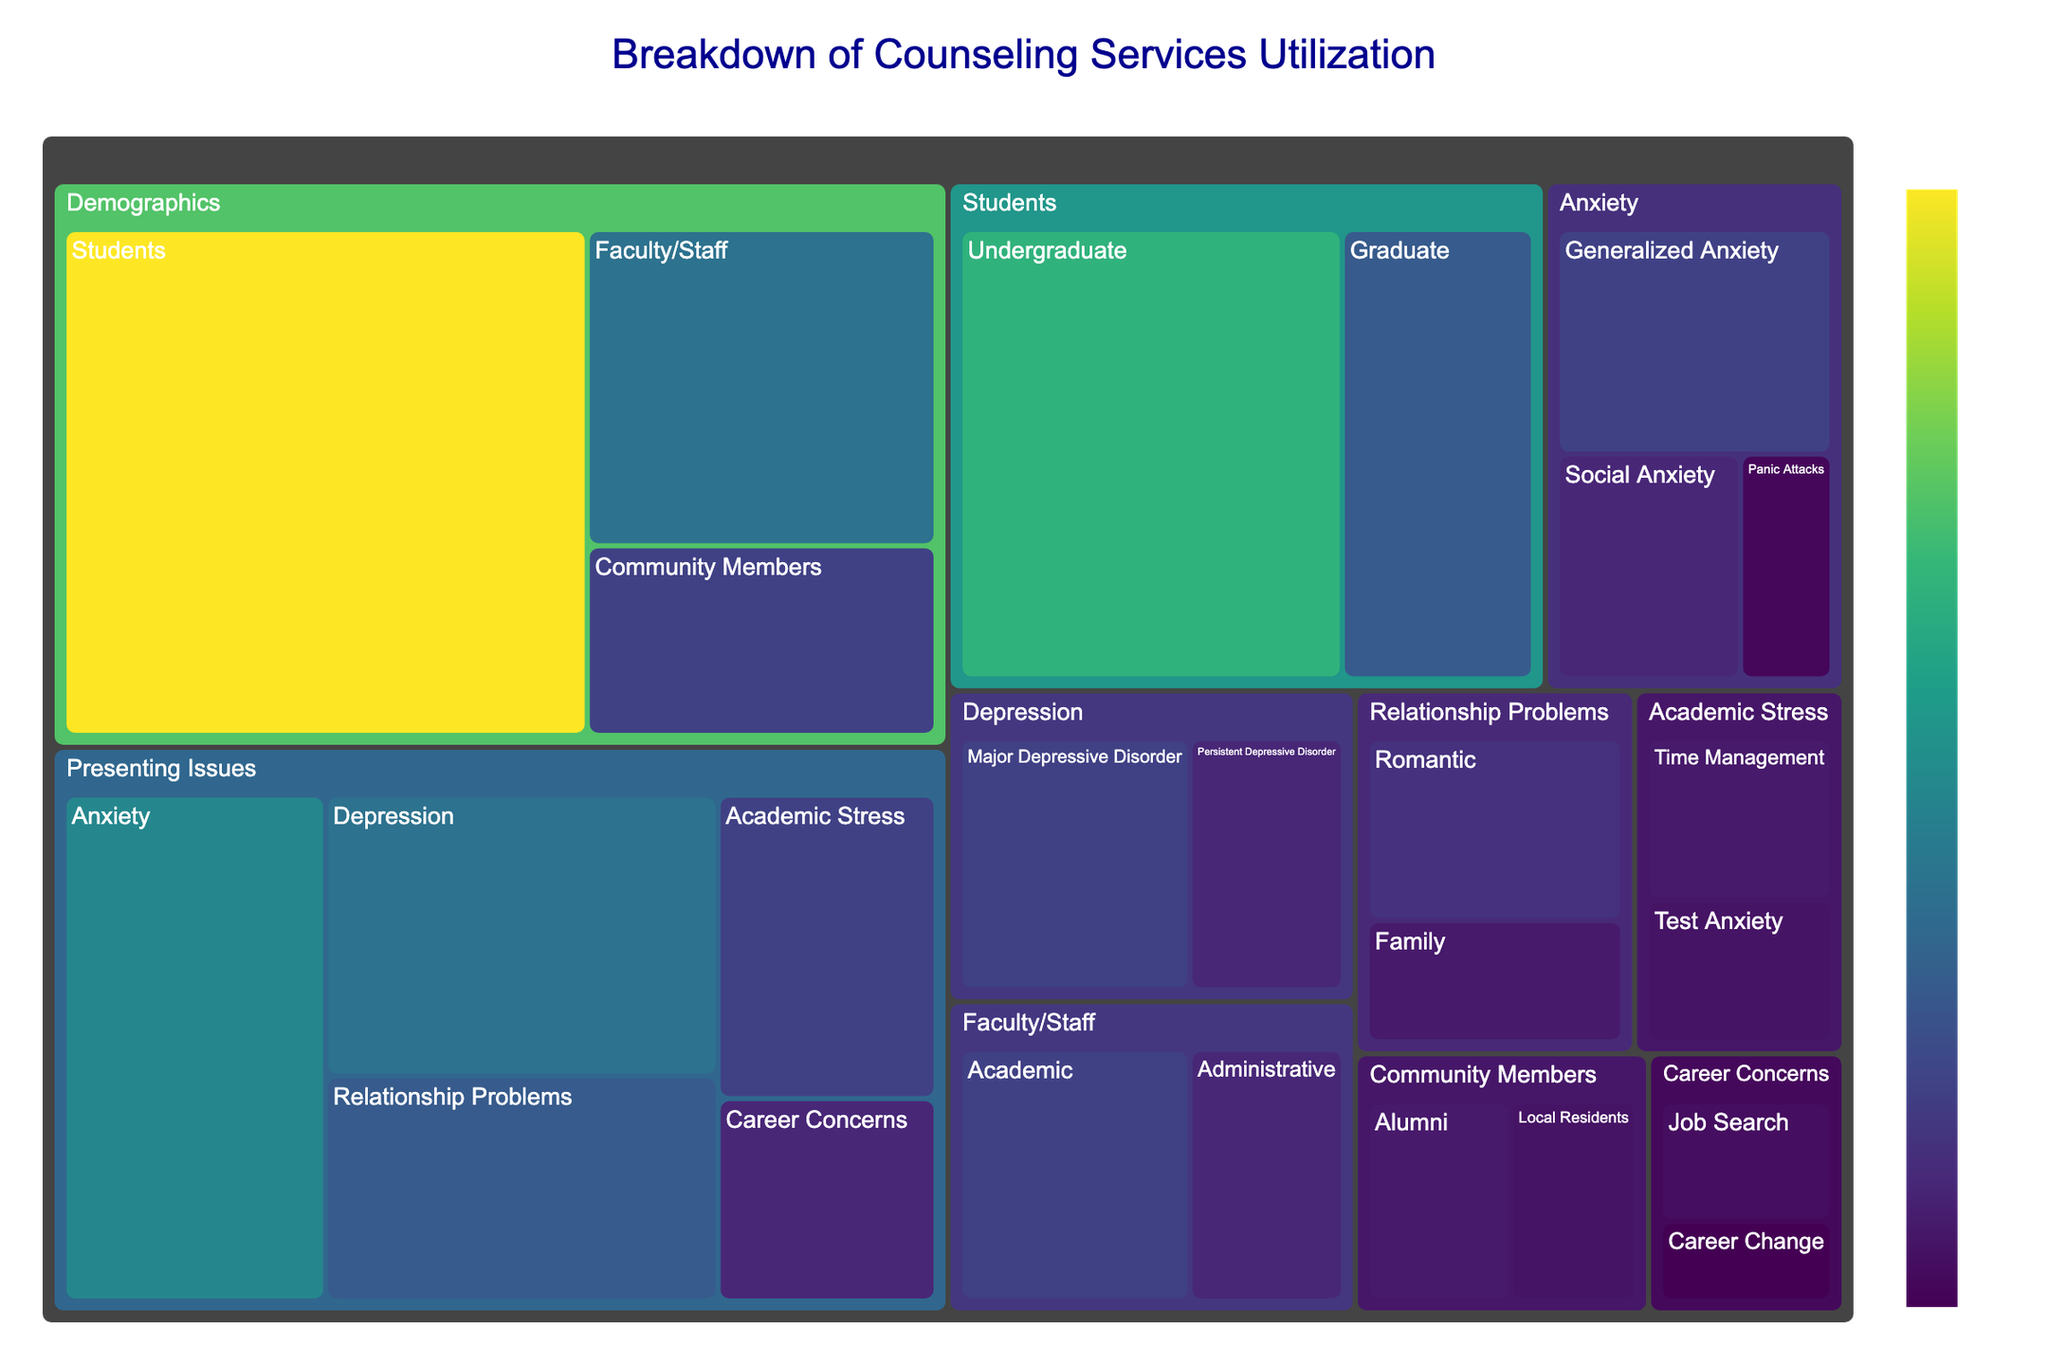1. What's the title of the treemap? The title is often displayed prominently at the top of the figure. For this treemap, the title is specified in the code.
Answer: Breakdown of Counseling Services Utilization 2. Which demographic category has the highest utilization of counseling services? By looking at the size of the blocks within the 'Demographics' category, the largest block represents the subcategory with the highest utilization.
Answer: Students 3. How many subcategories are under the 'Anxiety' presenting issue? In the treemap, under 'Presenting Issues' and then 'Anxiety', count the number of subcategories.
Answer: 3 4. What is the total utilization value for 'Faculty/Staff'? Sum the values of subcategories under 'Faculty/Staff'. That is 15 (Academic) + 10 (Administrative).
Answer: 25 5. Which category has the lowest single utilization value, and what is that value? Look for the smallest block in terms of size and value. 'Career Concerns' has subcategories with values of 6 and 4. The smallest is 4.
Answer: Career Concerns, 4 6. Comparing 'Undergraduate' and 'Graduate' students, which group has higher utilization and by how much? From the 'Students' subcategory, Undergraduates have a value of 40 and Graduates have a value of 20. Subtract Graduate value from Undergraduate value.
Answer: Undergraduates, 20 (higher by 20) 7. What is the total utilization for 'Presenting Issues'? Add up the values of all subcategories under 'Presenting Issues'. 30 (Anxiety) + 25 (Depression) + 20 (Relationship Problems) + 15 (Academic Stress) + 10 (Career Concerns).
Answer: 100 8. What's the most common presenting issue among clients? Within the 'Presenting Issues' category, the largest subcategory block represents the most common issue.
Answer: Anxiety 9. How does the utilization of 'Local Residents' compare to 'Alumni'? Examine the size of the blocks under 'Community Members'. Local Residents have a value of 7, and Alumni have a value of 8.
Answer: Alumni is higher by 1 10. Calculate the average utilization for 'Academic Stress' subcategories. The 'Academic Stress' category has two subcategories, so sum their values and divide by the number of subcategories. (8 + 7) / 2 = 15 / 2.
Answer: 7.5 